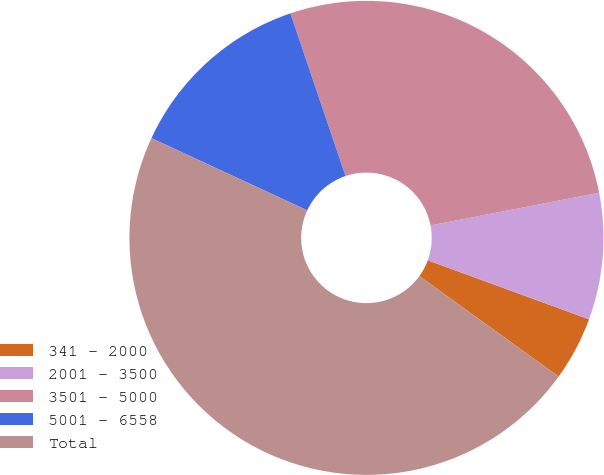Convert chart. <chart><loc_0><loc_0><loc_500><loc_500><pie_chart><fcel>341 - 2000<fcel>2001 - 3500<fcel>3501 - 5000<fcel>5001 - 6558<fcel>Total<nl><fcel>4.37%<fcel>8.63%<fcel>27.15%<fcel>12.89%<fcel>46.96%<nl></chart> 